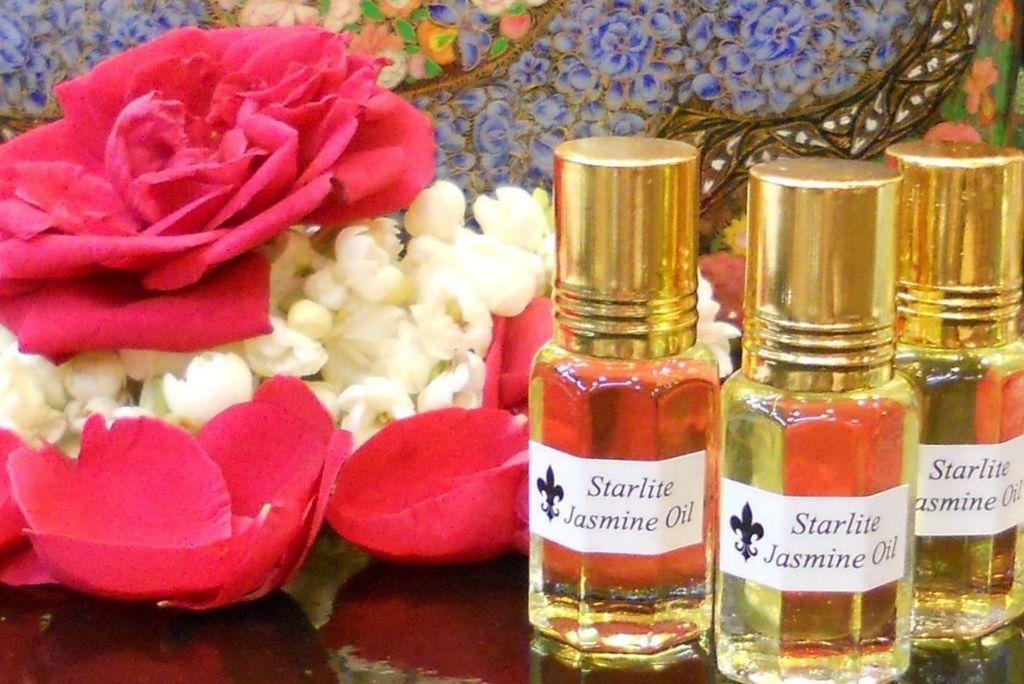<image>
Present a compact description of the photo's key features. Three bottles of Starlite Jasmine Oil sit next to a flower. 